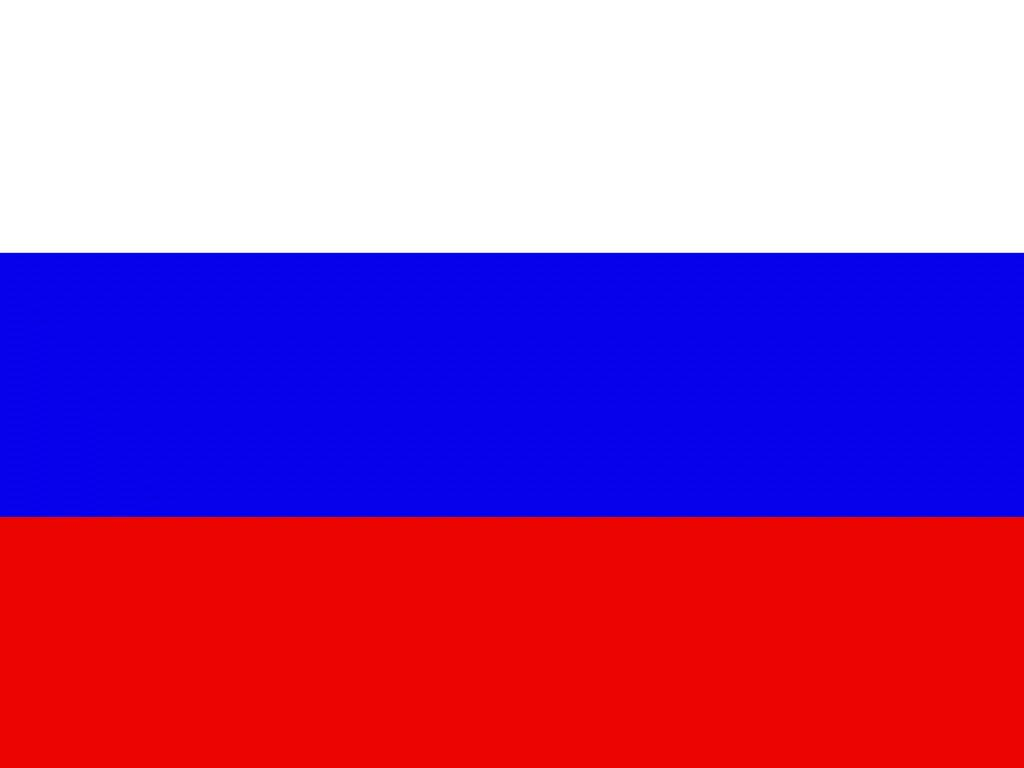What can be seen in the image? There are color stripes in the image. Can you describe the appearance of the color stripes? The color stripes are made up of various colors arranged in a pattern. How much poison is present in the color stripes in the image? There is no poison present in the color stripes in the image. The image only contains color stripes, and there is no indication of any poisonous substances. 